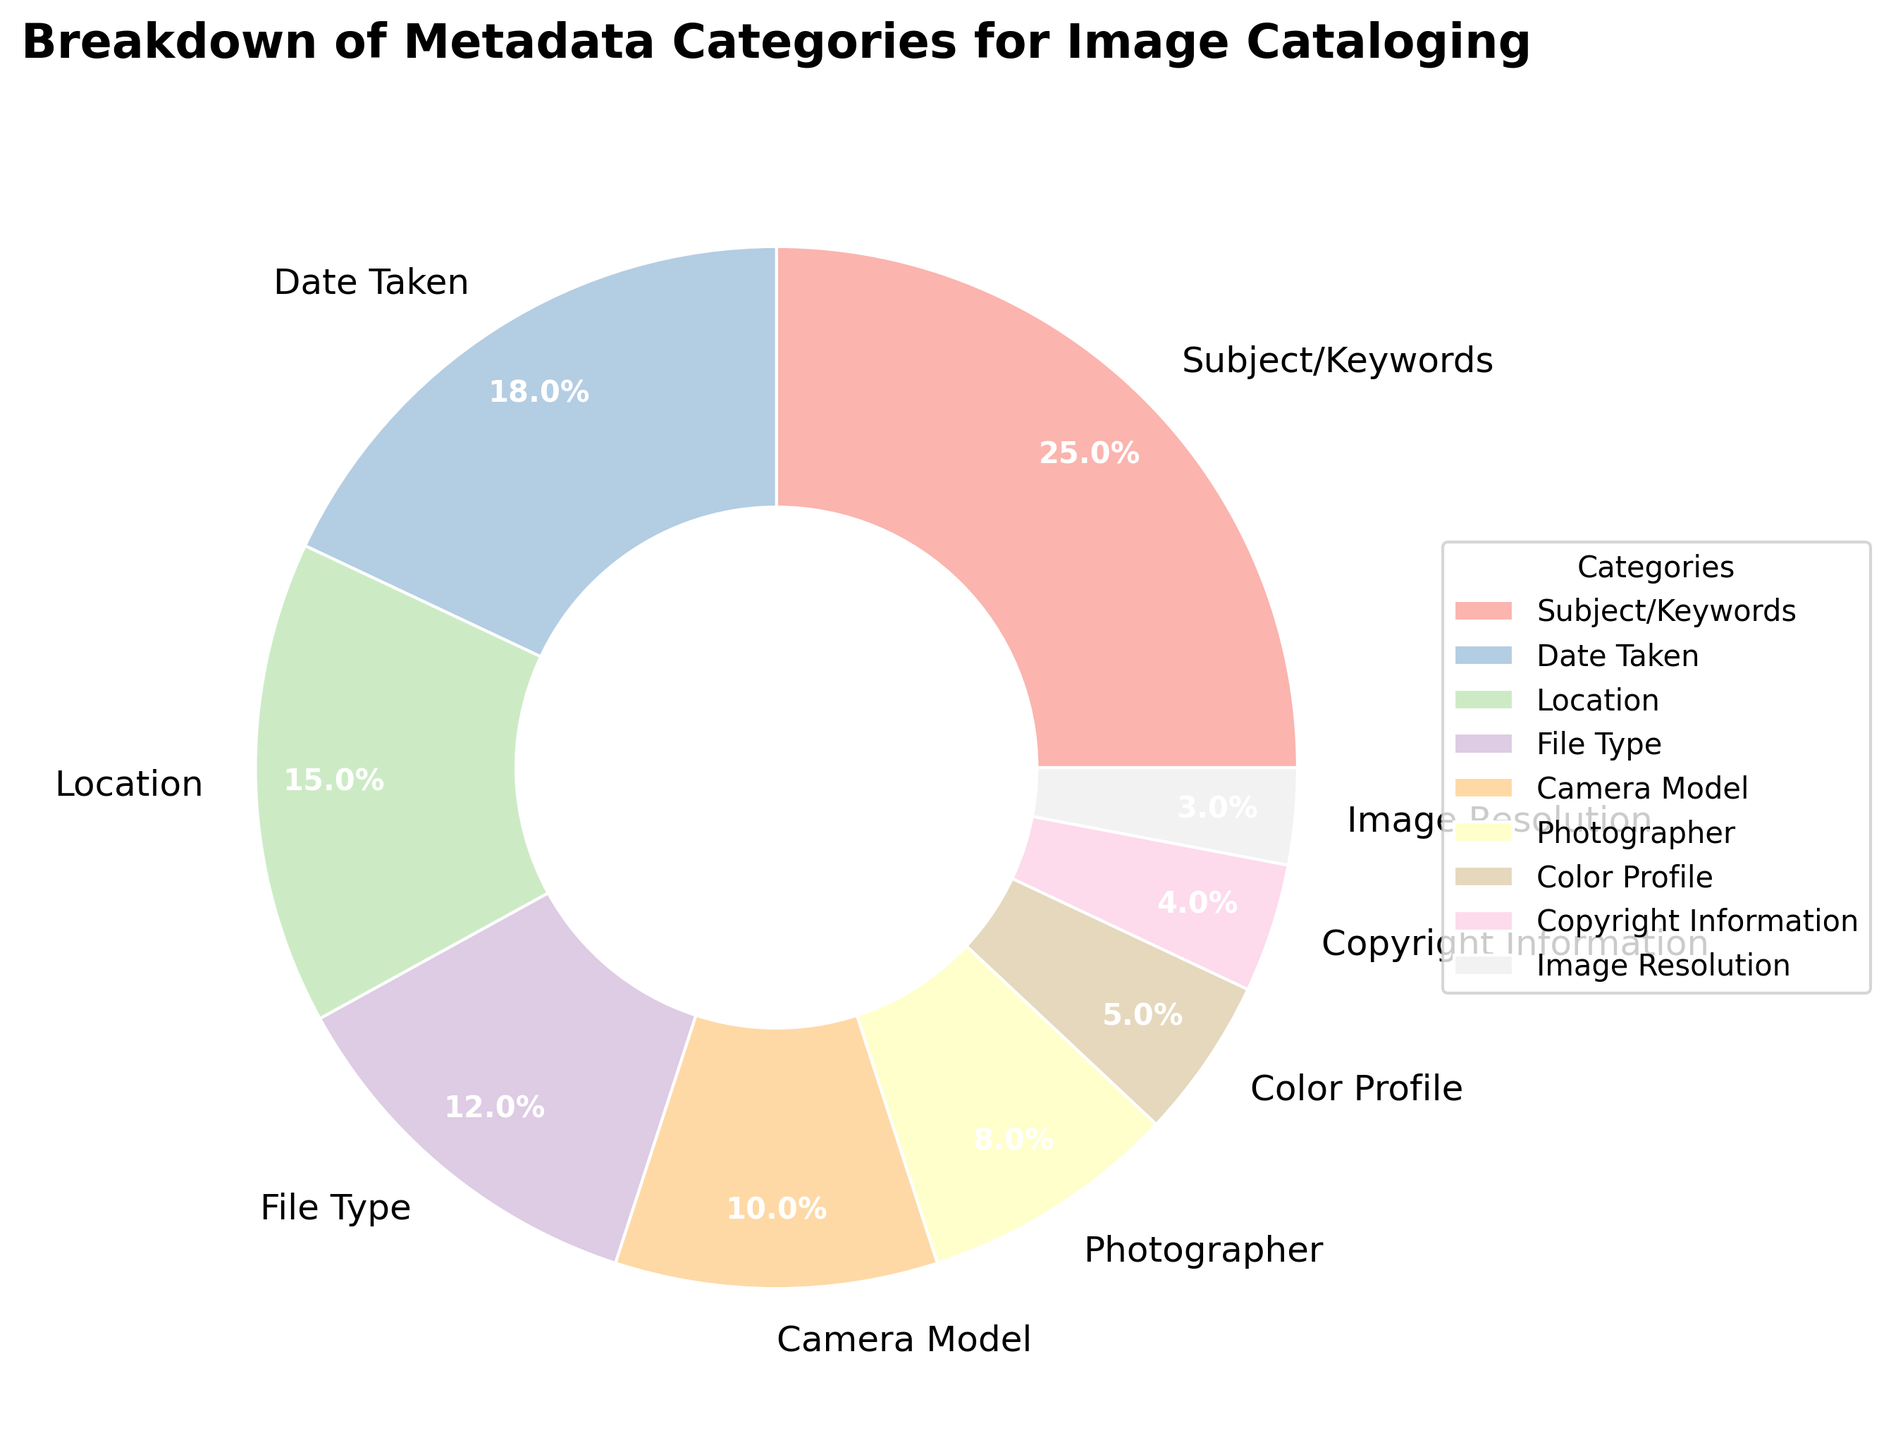Which metadata category has the highest percentage? The wedge representing "Subject/Keywords" has the largest size and is labeled as 25%.
Answer: Subject/Keywords What is the combined percentage of 'Date Taken' and 'Location'? 'Date Taken' is 18% and 'Location' is 15%. Adding these together gives 18% + 15% = 33%.
Answer: 33% Which categories have a percentage less than 10%? The slices labeled 'Photographer' (8%), 'Color Profile' (5%), 'Copyright Information' (4%), and 'Image Resolution' (3%) are all under 10%.
Answer: Photographer, Color Profile, Copyright Information, Image Resolution How much larger is the percentage of 'File Type' compared to 'Image Resolution'? 'File Type' is 12% and 'Image Resolution' is 3%. The difference is 12% - 3% = 9%.
Answer: 9% Which two categories together make up 20%? 'Camera Model' and 'Photographer' are 10% and 8%, respectively. Together, they sum to 10% + 8% = 18%, which is close but not 20%. Instead, 'Color Profile' (5%) and 'Copyright Information' (4%) together do not sum to 20%. Finally, 'Color Profile' (5%) and 'Image Resolution' (3%) together sum to 8%, which also does not sum to 20%. None fit exactly, but 'Color Profile' and 'Image Resolution' together are the closest provided.
Answer: None fit exactly What is the difference in percentage between the largest and smallest categories? 'Subject/Keywords' is 25% and 'Image Resolution' is 3%. The difference is 25% - 3% = 22%.
Answer: 22% Which category has a noticeable lighter color than 'Date Taken'? By visual inspection, 'Camera Model' appears with a noticeably lighter color compared to 'Date Taken'.
Answer: Camera Model How many categories have percentages 5% or lower? The categories 'Color Profile' (5%), 'Copyright Information' (4%), and 'Image Resolution' (3%) each have percentages 5% or lower. This results in 3 categories.
Answer: 3 Compare the percentage of 'Camera Model' with 'Photographer'. 'Camera Model' is 10% and 'Photographer' is 8%, making 'Camera Model' 2% higher than 'Photographer'.
Answer: Camera Model is 2% higher 